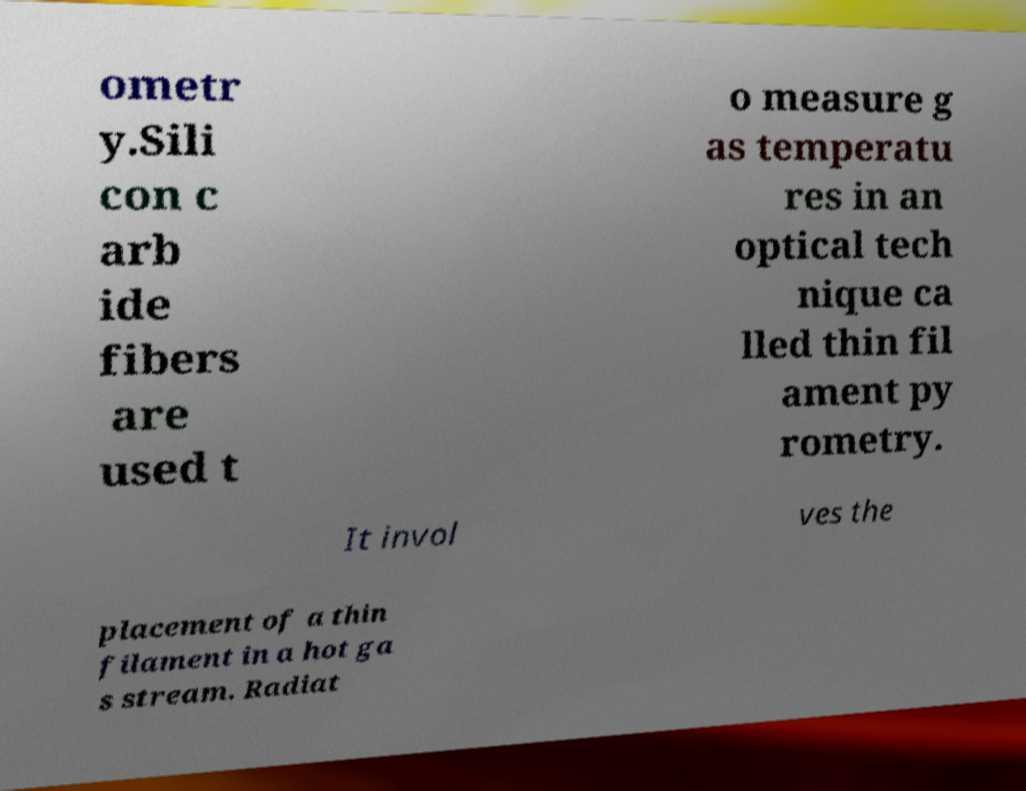For documentation purposes, I need the text within this image transcribed. Could you provide that? ometr y.Sili con c arb ide fibers are used t o measure g as temperatu res in an optical tech nique ca lled thin fil ament py rometry. It invol ves the placement of a thin filament in a hot ga s stream. Radiat 